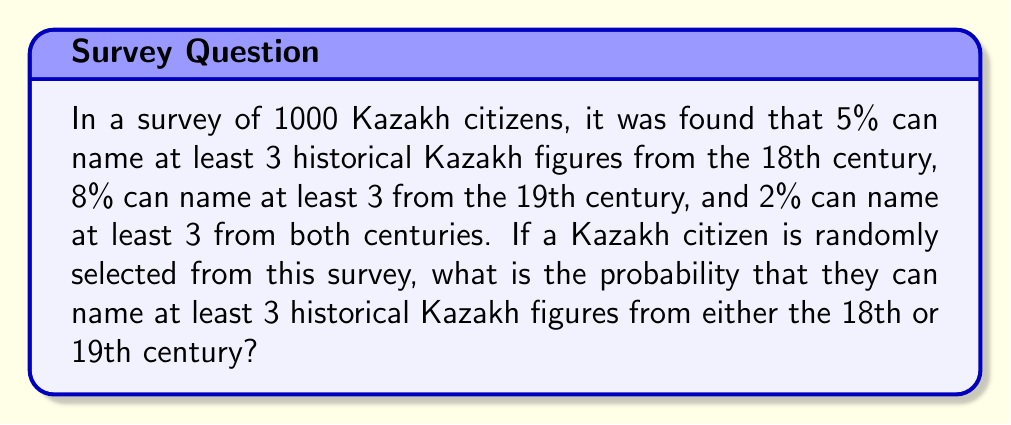What is the answer to this math problem? Let's approach this step-by-step using set theory and the addition rule of probability:

1) Let A be the event of naming at least 3 historical Kazakh figures from the 18th century.
   P(A) = 5% = 0.05

2) Let B be the event of naming at least 3 historical Kazakh figures from the 19th century.
   P(B) = 8% = 0.08

3) We're given that P(A ∩ B) = 2% = 0.02

4) We want to find P(A ∪ B), which is the probability of naming at least 3 historical Kazakh figures from either century.

5) We can use the addition rule of probability:
   
   $$P(A ∪ B) = P(A) + P(B) - P(A ∩ B)$$

6) Substituting the values:

   $$P(A ∪ B) = 0.05 + 0.08 - 0.02$$

7) Calculating:

   $$P(A ∪ B) = 0.11 = 11\%$$

Therefore, the probability that a randomly selected Kazakh citizen from this survey can name at least 3 historical Kazakh figures from either the 18th or 19th century is 11%.
Answer: 11% or 0.11 